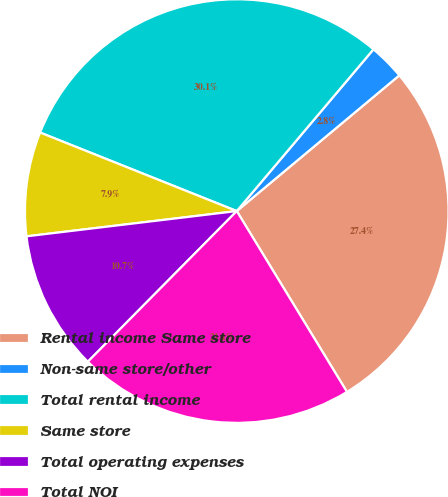Convert chart. <chart><loc_0><loc_0><loc_500><loc_500><pie_chart><fcel>Rental income Same store<fcel>Non-same store/other<fcel>Total rental income<fcel>Same store<fcel>Total operating expenses<fcel>Total NOI<nl><fcel>27.36%<fcel>2.76%<fcel>30.12%<fcel>7.95%<fcel>10.69%<fcel>21.12%<nl></chart> 